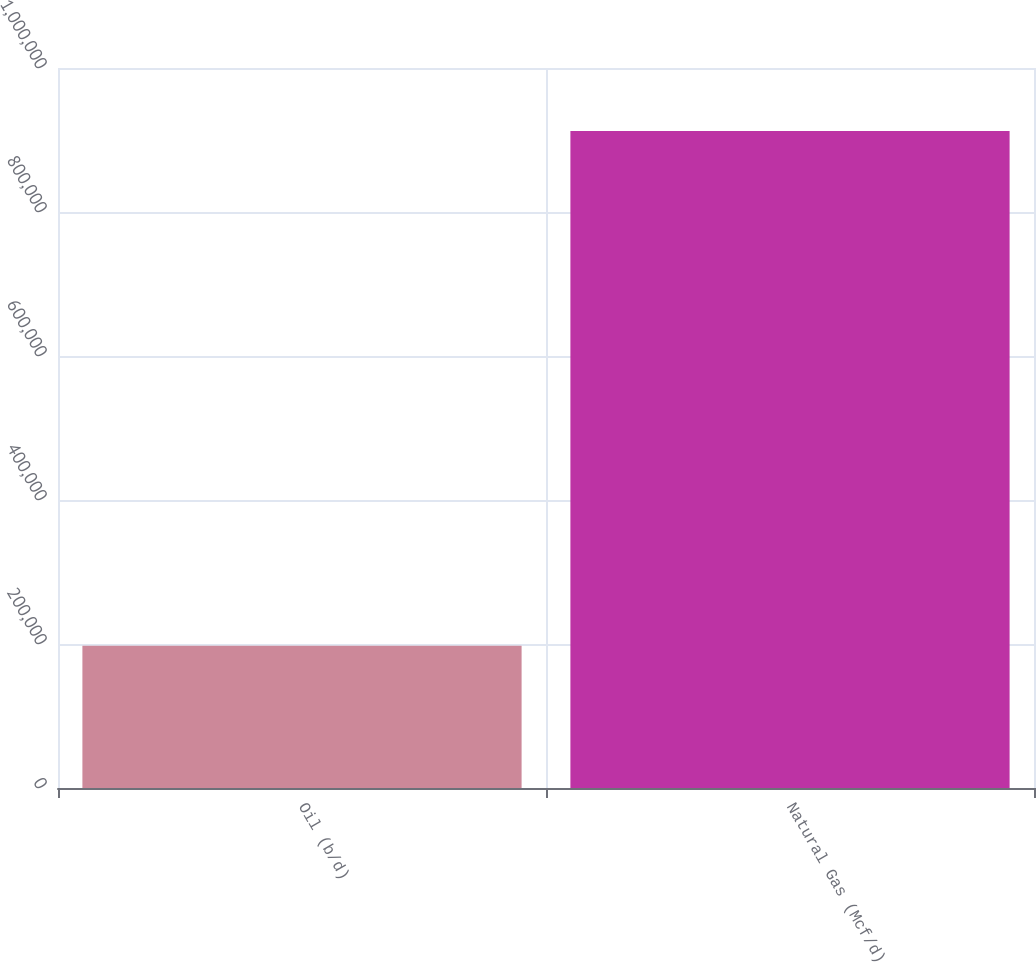Convert chart to OTSL. <chart><loc_0><loc_0><loc_500><loc_500><bar_chart><fcel>Oil (b/d)<fcel>Natural Gas (Mcf/d)<nl><fcel>197622<fcel>912478<nl></chart> 